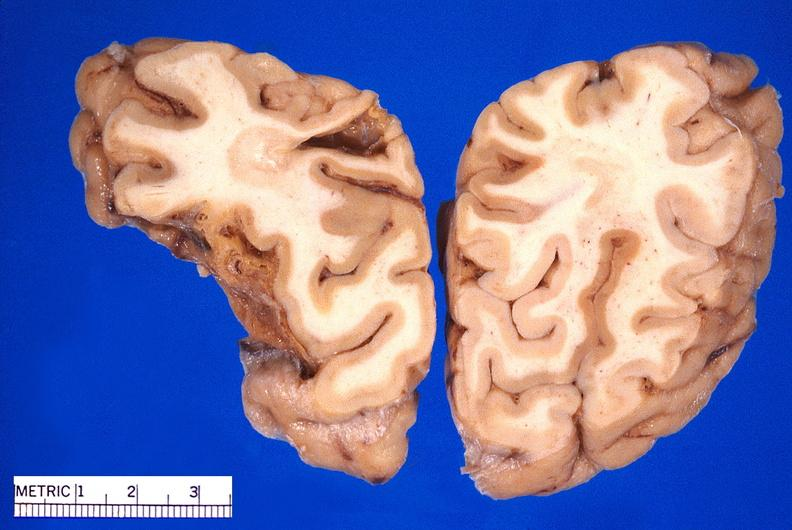does malignant lymphoma large cell type show brain, old infarcts, embolic?
Answer the question using a single word or phrase. No 